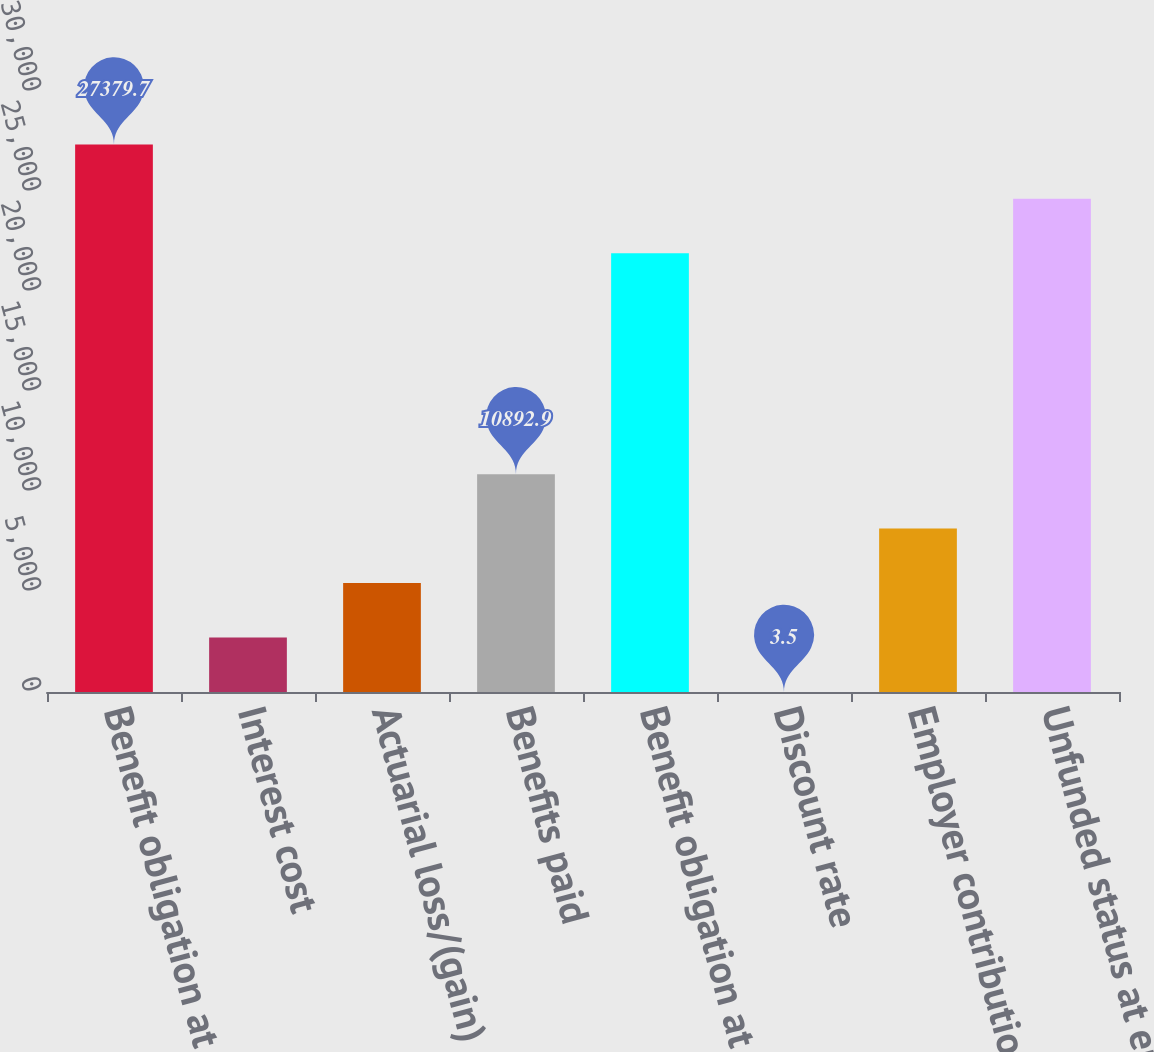<chart> <loc_0><loc_0><loc_500><loc_500><bar_chart><fcel>Benefit obligation at<fcel>Interest cost<fcel>Actuarial loss/(gain)<fcel>Benefits paid<fcel>Benefit obligation at end of<fcel>Discount rate<fcel>Employer contributions<fcel>Unfunded status at end of year<nl><fcel>27379.7<fcel>2725.85<fcel>5448.2<fcel>10892.9<fcel>21935<fcel>3.5<fcel>8170.55<fcel>24657.3<nl></chart> 